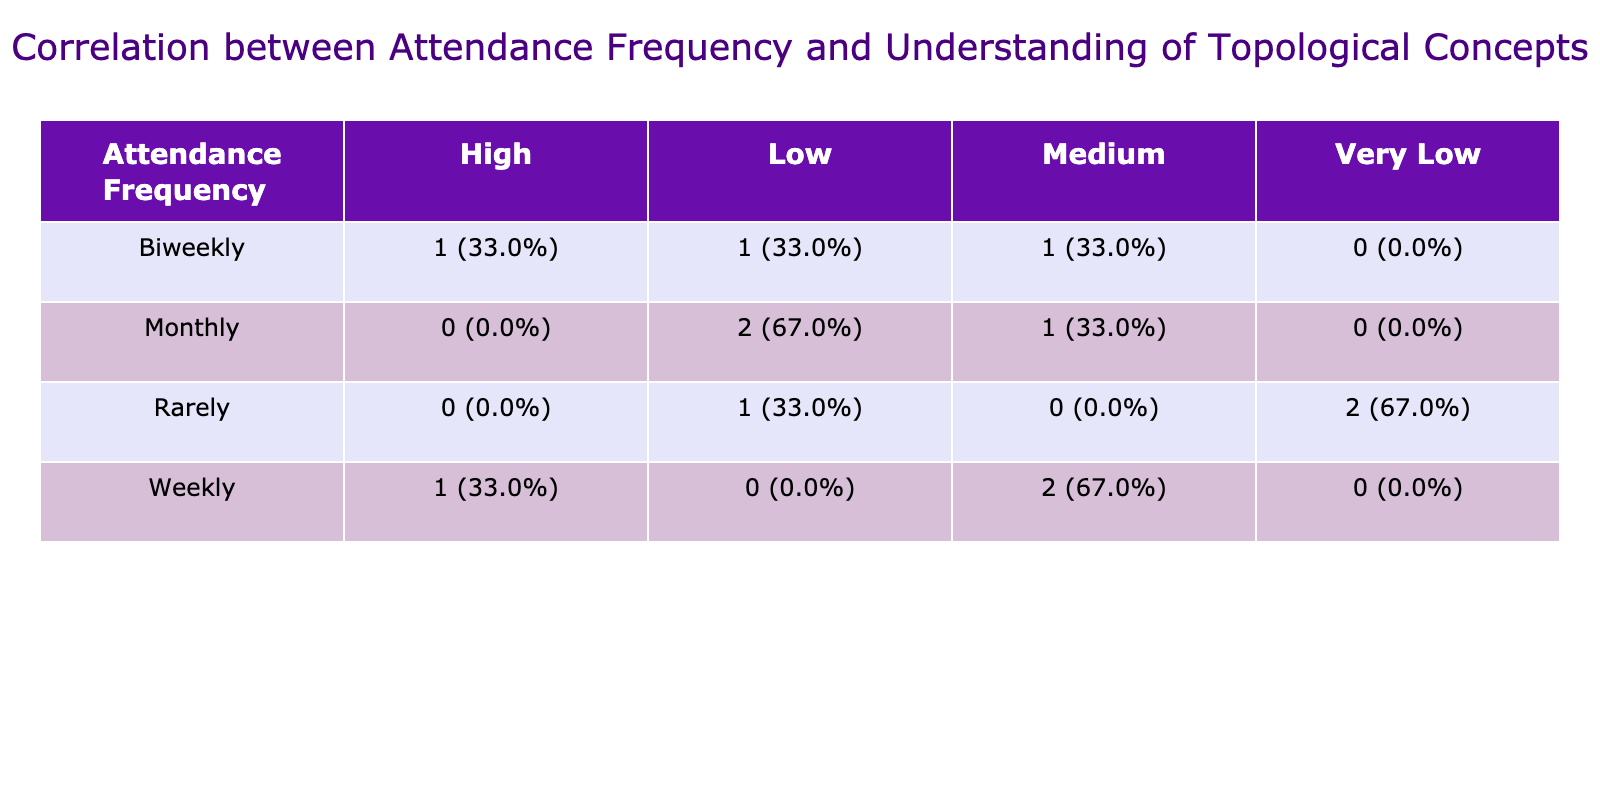What is the count of individuals who attend biweekly with a high understanding of topological concepts? According to the table, under the attendance frequency "Biweekly," there is 1 count for the "High" understanding category.
Answer: 1 How many individuals attend monthly and have a low understanding of topological concepts? The table shows that under the attendance frequency "Monthly," there are 3 individuals with a "Low" understanding.
Answer: 3 Is there anyone who attends rarely and has a high understanding of topological concepts? The table indicates that there are 0 individuals who are in the "Rarely" category with "High" understanding, as no such entry exists.
Answer: No What is the percentage of individuals with medium understanding who attend weekly? Under the "Weekly" attendance category, there are 2 individuals with "Medium" understanding among a total of 4 individuals. The percentage is (2/4) * 100 = 50%.
Answer: 50% What is the total number of individuals who have a very low understanding of topological concepts? To find this, we look at the "Very Low" category across all attendance frequencies. There are 2 individuals listed as "Very Low" under "Rarely." Thus, the total count is 2.
Answer: 2 How many more individuals attend biweekly with high understanding compared to monthly with high understanding? For biweekly, there is 1 individual with "High" understanding, while for monthly, there are 0 individuals. The difference is 1 - 0 = 1.
Answer: 1 What is the ratio of individuals who attend weekly to those who have low understanding of topological concepts? There are 4 individuals who attend weekly and 3 who have a "Low" understanding overall (from both monthly and rarely). The ratio of individuals attending weekly to those with low understanding is 4:3.
Answer: 4:3 Are there any individuals with low understanding who attend every month? Yes, according to the table, there are 3 individuals with "Low" understanding who attend monthly, as specified under that category.
Answer: Yes 